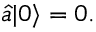Convert formula to latex. <formula><loc_0><loc_0><loc_500><loc_500>{ \hat { a } } | 0 \rangle = 0 .</formula> 